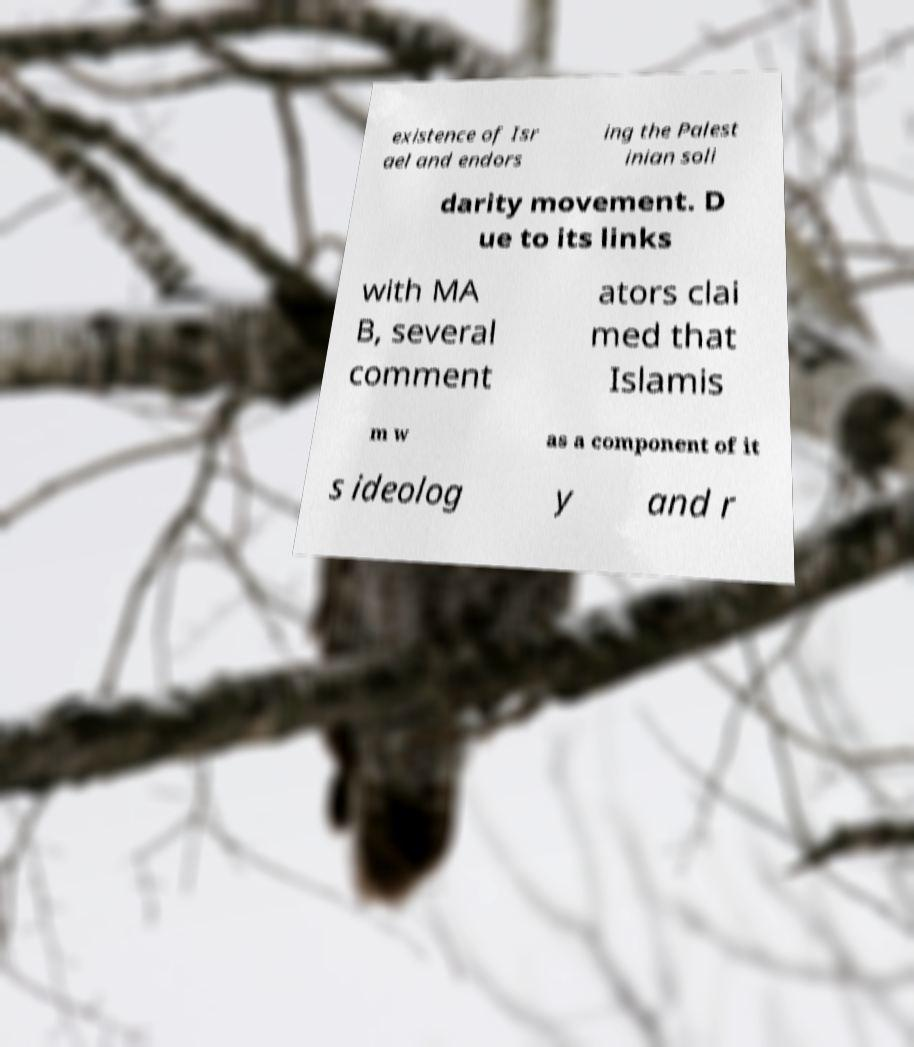I need the written content from this picture converted into text. Can you do that? existence of Isr ael and endors ing the Palest inian soli darity movement. D ue to its links with MA B, several comment ators clai med that Islamis m w as a component of it s ideolog y and r 